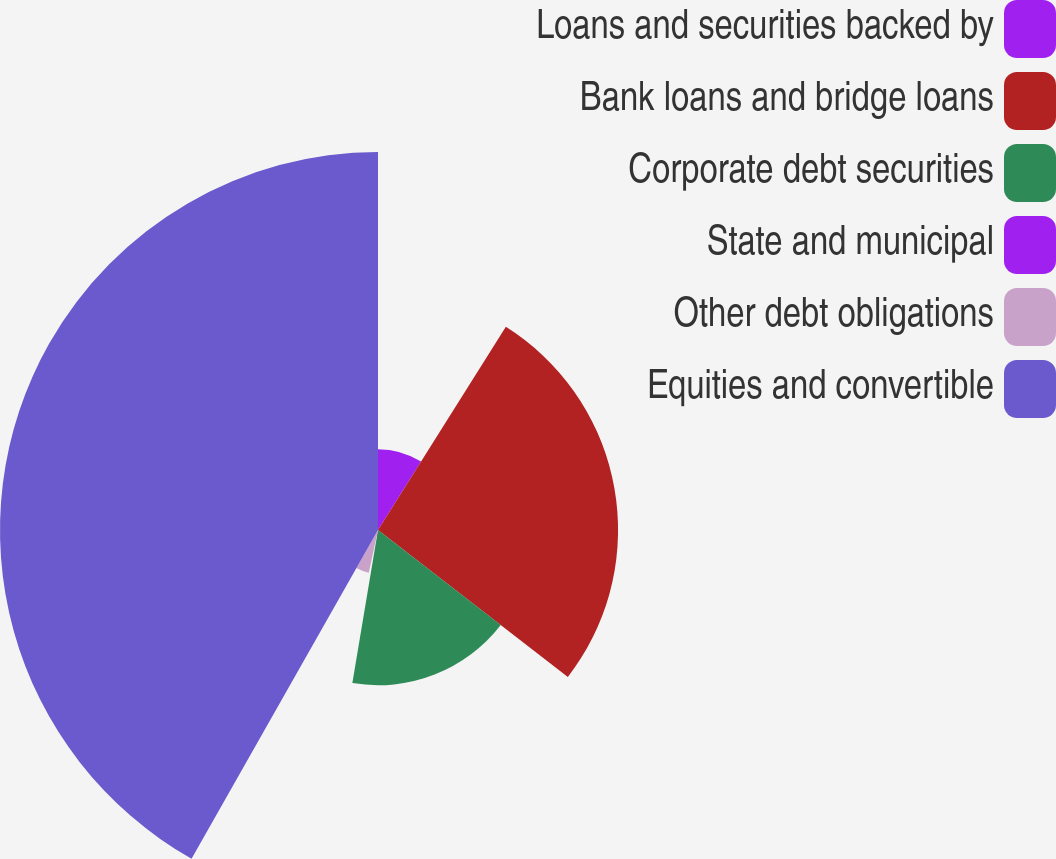<chart> <loc_0><loc_0><loc_500><loc_500><pie_chart><fcel>Loans and securities backed by<fcel>Bank loans and bridge loans<fcel>Corporate debt securities<fcel>State and municipal<fcel>Other debt obligations<fcel>Equities and convertible<nl><fcel>8.94%<fcel>26.54%<fcel>17.16%<fcel>0.73%<fcel>4.84%<fcel>41.79%<nl></chart> 